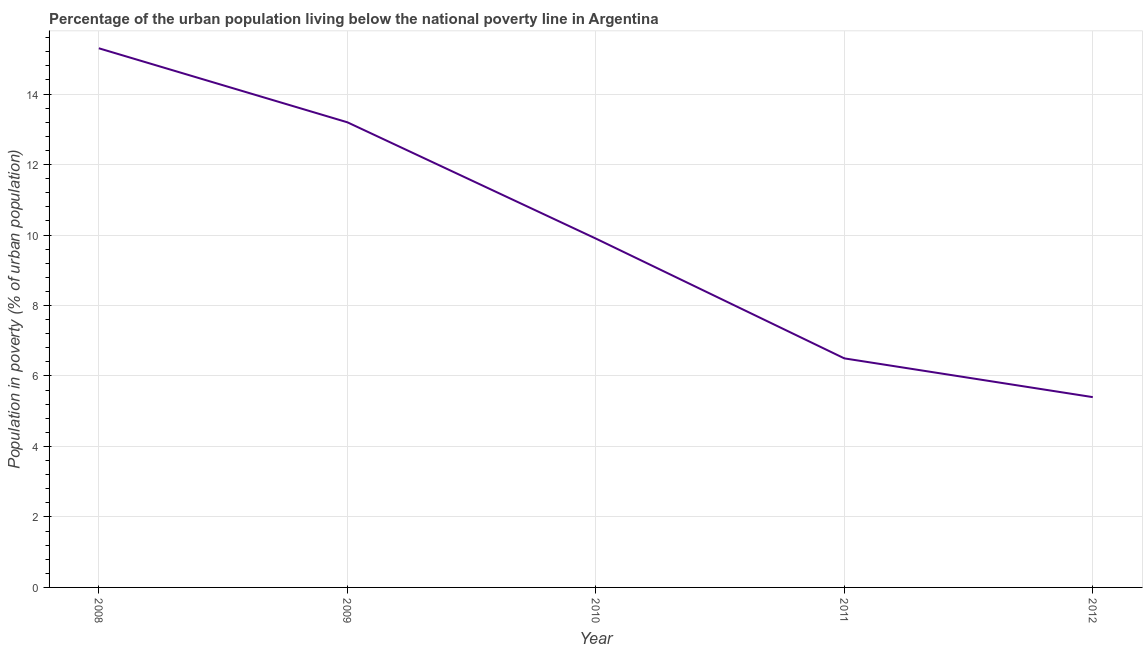In which year was the percentage of urban population living below poverty line maximum?
Make the answer very short. 2008. In which year was the percentage of urban population living below poverty line minimum?
Offer a terse response. 2012. What is the sum of the percentage of urban population living below poverty line?
Your response must be concise. 50.3. What is the difference between the percentage of urban population living below poverty line in 2009 and 2010?
Your response must be concise. 3.3. What is the average percentage of urban population living below poverty line per year?
Your answer should be very brief. 10.06. Do a majority of the years between 2010 and 2011 (inclusive) have percentage of urban population living below poverty line greater than 13.2 %?
Provide a short and direct response. No. What is the ratio of the percentage of urban population living below poverty line in 2008 to that in 2011?
Keep it short and to the point. 2.35. Is the percentage of urban population living below poverty line in 2008 less than that in 2011?
Your answer should be very brief. No. What is the difference between the highest and the second highest percentage of urban population living below poverty line?
Make the answer very short. 2.1. Is the sum of the percentage of urban population living below poverty line in 2010 and 2011 greater than the maximum percentage of urban population living below poverty line across all years?
Provide a short and direct response. Yes. In how many years, is the percentage of urban population living below poverty line greater than the average percentage of urban population living below poverty line taken over all years?
Ensure brevity in your answer.  2. How many lines are there?
Give a very brief answer. 1. What is the title of the graph?
Offer a very short reply. Percentage of the urban population living below the national poverty line in Argentina. What is the label or title of the X-axis?
Offer a very short reply. Year. What is the label or title of the Y-axis?
Your answer should be very brief. Population in poverty (% of urban population). What is the Population in poverty (% of urban population) of 2008?
Offer a terse response. 15.3. What is the Population in poverty (% of urban population) in 2009?
Your answer should be compact. 13.2. What is the Population in poverty (% of urban population) in 2012?
Make the answer very short. 5.4. What is the difference between the Population in poverty (% of urban population) in 2009 and 2010?
Your response must be concise. 3.3. What is the difference between the Population in poverty (% of urban population) in 2011 and 2012?
Make the answer very short. 1.1. What is the ratio of the Population in poverty (% of urban population) in 2008 to that in 2009?
Make the answer very short. 1.16. What is the ratio of the Population in poverty (% of urban population) in 2008 to that in 2010?
Make the answer very short. 1.54. What is the ratio of the Population in poverty (% of urban population) in 2008 to that in 2011?
Give a very brief answer. 2.35. What is the ratio of the Population in poverty (% of urban population) in 2008 to that in 2012?
Provide a succinct answer. 2.83. What is the ratio of the Population in poverty (% of urban population) in 2009 to that in 2010?
Give a very brief answer. 1.33. What is the ratio of the Population in poverty (% of urban population) in 2009 to that in 2011?
Offer a very short reply. 2.03. What is the ratio of the Population in poverty (% of urban population) in 2009 to that in 2012?
Offer a terse response. 2.44. What is the ratio of the Population in poverty (% of urban population) in 2010 to that in 2011?
Your response must be concise. 1.52. What is the ratio of the Population in poverty (% of urban population) in 2010 to that in 2012?
Your response must be concise. 1.83. What is the ratio of the Population in poverty (% of urban population) in 2011 to that in 2012?
Make the answer very short. 1.2. 